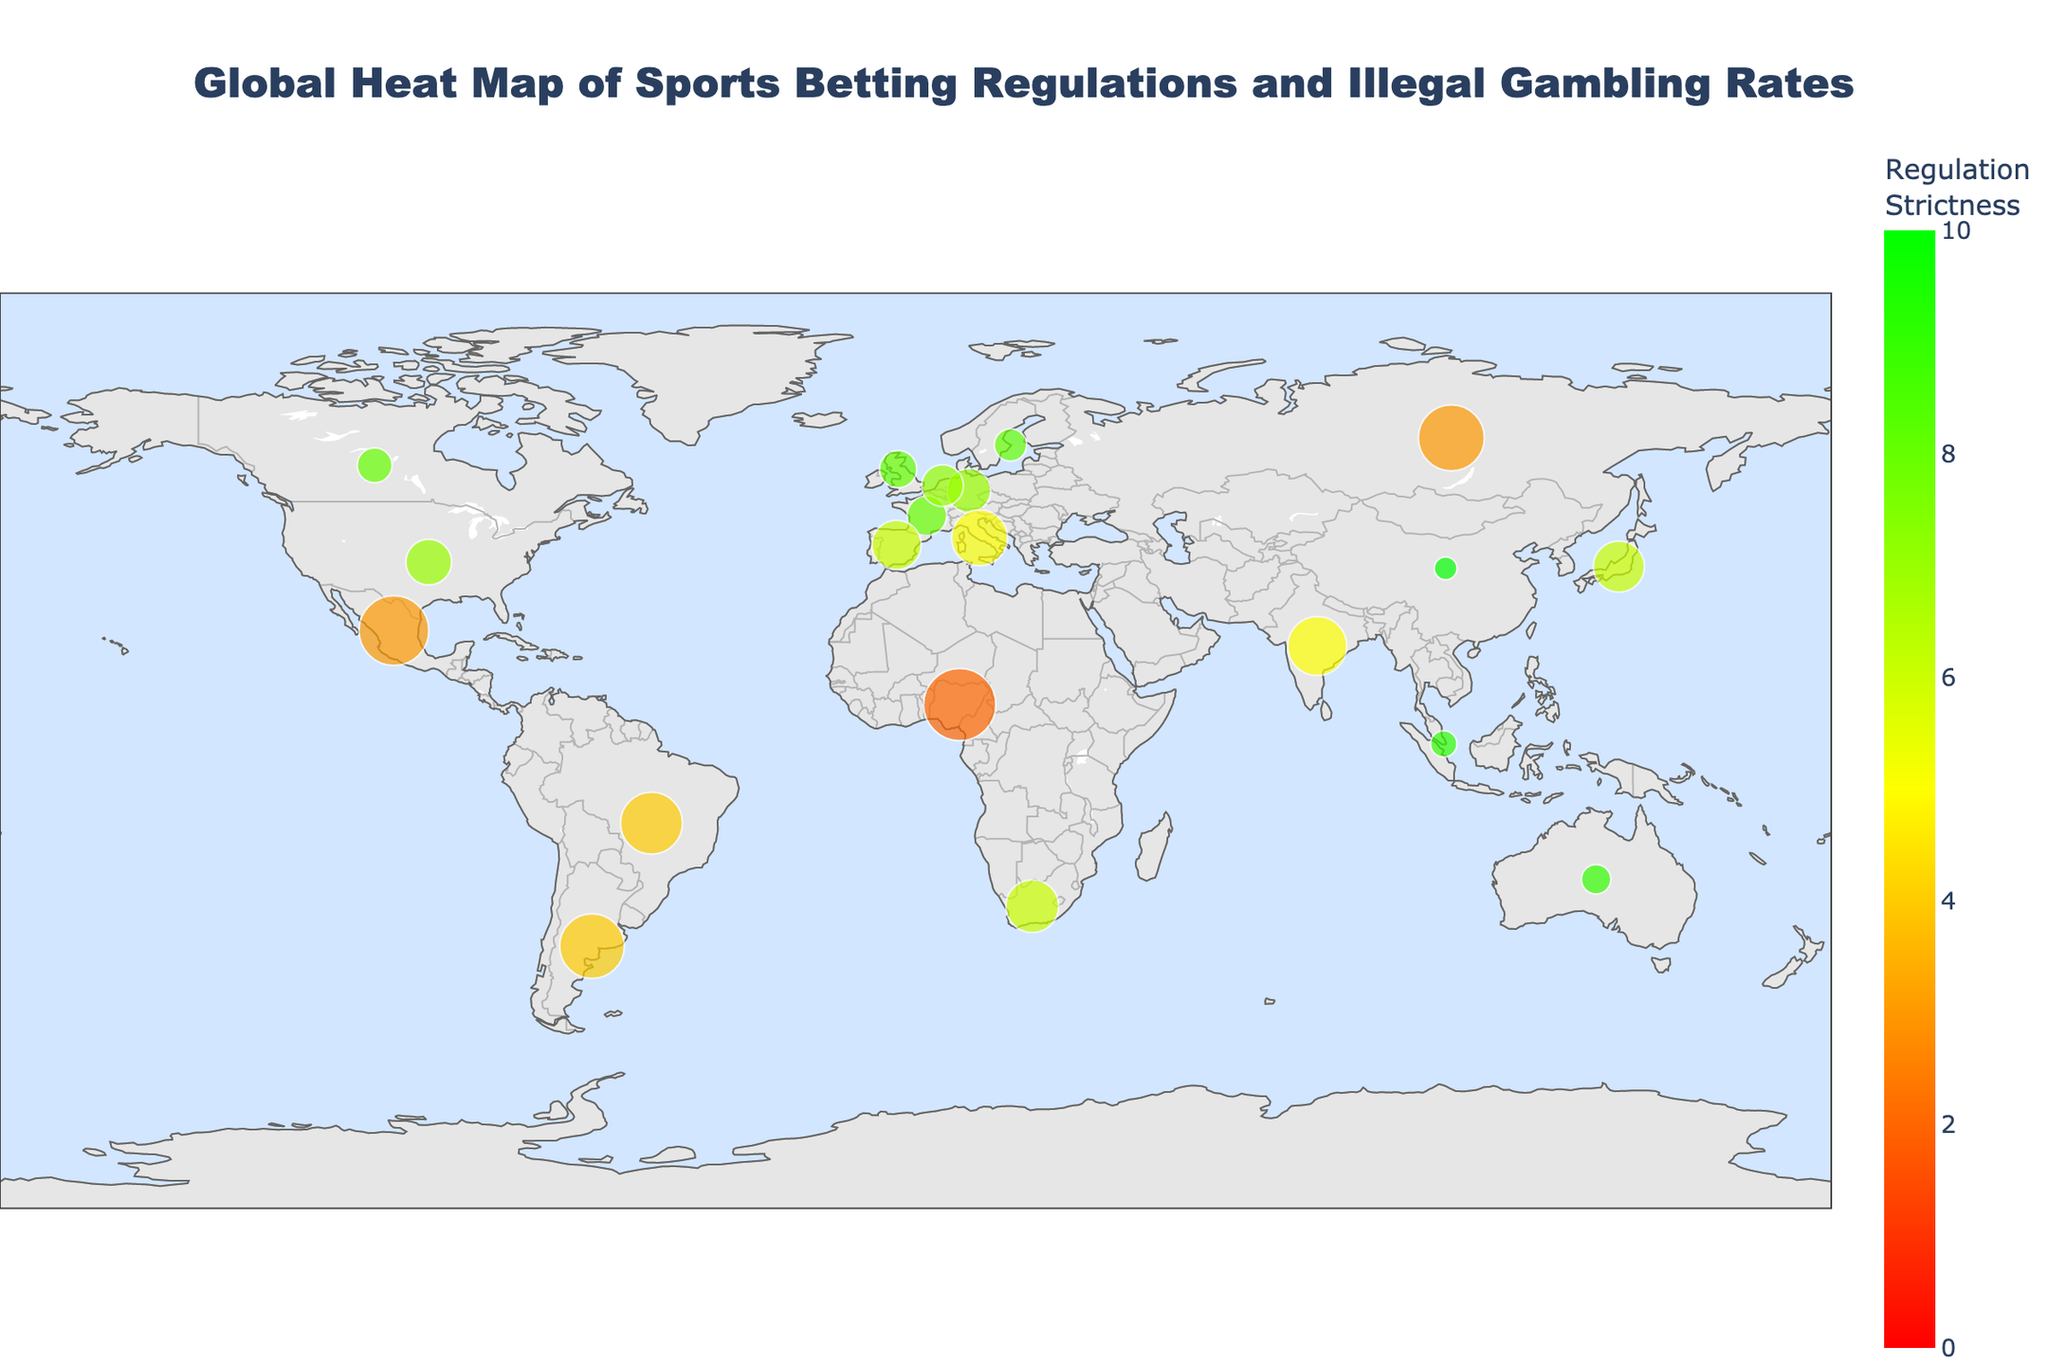What's the title of the figure? The title of the figure is usually displayed prominently at the top.
Answer: Global Heat Map of Sports Betting Regulations and Illegal Gambling Rates How many countries are represented in the figure? Count the number of distinct data points or labels on the map, each representing a country.
Answer: 19 Which country has the highest regulation strictness and what is its illegal gambling rate? Find the country with the highest value in the color spectrum. The strictness and rate values are usually labeled or can be found in the tooltip when hovering.
Answer: China, 3% What is the illegal gambling rate for countries with regulation strictness of 8? Look for countries with the strictness value of 8 and note their illegal gambling rates, e.g., United Kingdom, France, Canada, and Sweden, then read their corresponding rates from the map.
Answer: United Kingdom: 8%, France: 9%, Canada: 7%, Sweden: 6% How does the illegal gambling rate in Brazil compare to Nigeria? Find Brazil and Nigeria on the map and note their illegal gambling rates, then compare them.
Answer: Brazil: 22%, Nigeria: 30% Which region has the highest concentration of countries with strict regulations (strictness of 7 or above)? Identify the geographical clusters on the map where countries with a regulation strictness of 7 or higher are located.
Answer: Europe What is the average illegal gambling rate for countries with a regulation strictness of 5? Identify countries with a regulation strictness value of 5 on the map, list their illegal gambling rates, and compute the average.
Answer: (18% + 20%) / 2 = 19% Which country has the largest size marker on the map and what does it indicate? The largest size marker represents the highest rate of illegal gambling. Identify this country on the map.
Answer: Nigeria Which regions generally have higher illegal gambling rates, those with strict regulations or less strict regulations? Compare the illegal gambling rates indicated by marker sizes in regions with high strictness (darker green) and low strictness (darker red) on the map.
Answer: Less strict regulations What trend can be inferred from the relationship between regulation strictness and illegal gambling rates in this figure? Observe the correlation between marker colors (regulation strictness) and marker sizes (illegal gambling rates) across the map to infer trends.
Answer: Generally, countries with stricter regulations tend to have lower illegal gambling rates 